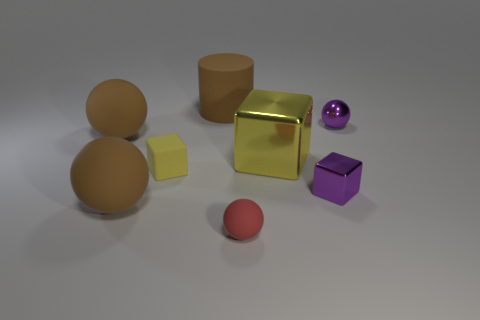Add 1 cyan shiny blocks. How many objects exist? 9 Subtract all cubes. How many objects are left? 5 Subtract all tiny yellow blocks. Subtract all large brown rubber balls. How many objects are left? 5 Add 5 tiny things. How many tiny things are left? 9 Add 5 large yellow metallic cubes. How many large yellow metallic cubes exist? 6 Subtract 0 gray cylinders. How many objects are left? 8 